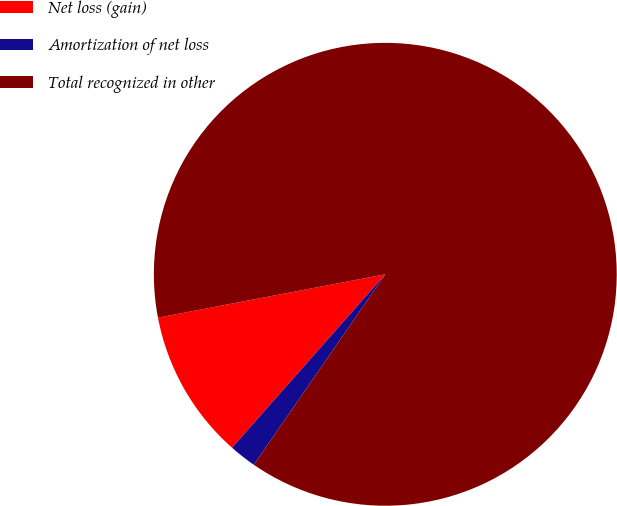<chart> <loc_0><loc_0><loc_500><loc_500><pie_chart><fcel>Net loss (gain)<fcel>Amortization of net loss<fcel>Total recognized in other<nl><fcel>10.48%<fcel>1.9%<fcel>87.62%<nl></chart> 